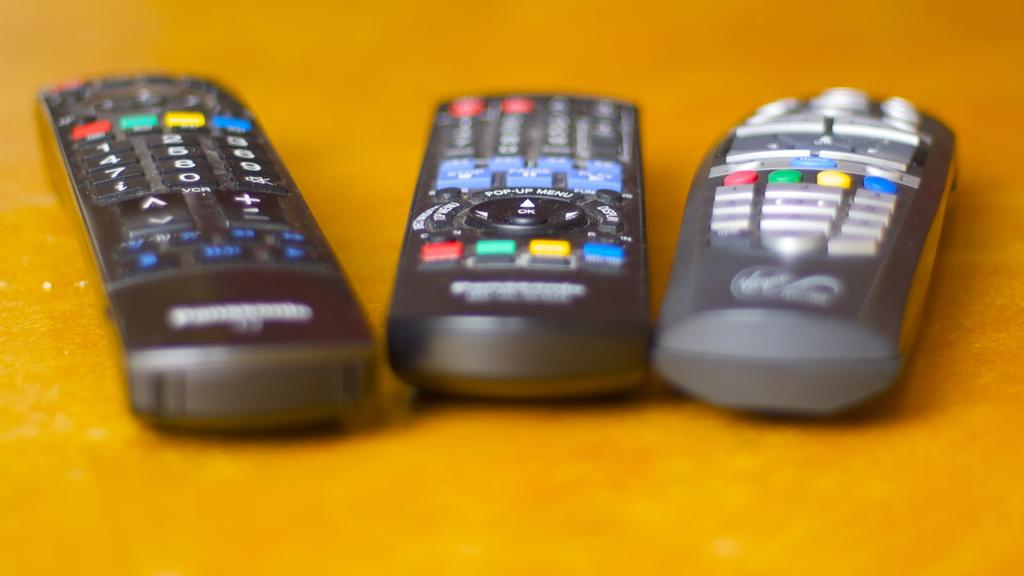How many remotes are visible in the image? There are three remotes in the image. What is the color of the surface on which the remotes are placed? The remotes are on a yellow color surface. How many snakes are slithering on the yellow surface in the image? There are no snakes present in the image. 